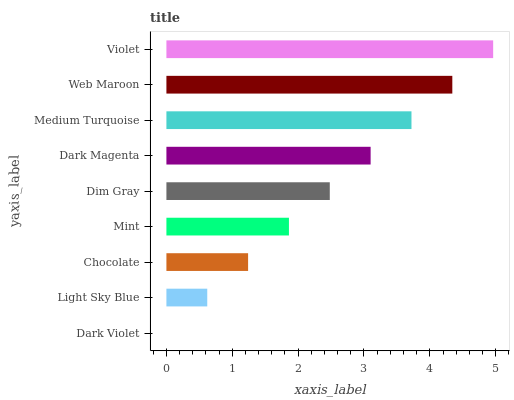Is Dark Violet the minimum?
Answer yes or no. Yes. Is Violet the maximum?
Answer yes or no. Yes. Is Light Sky Blue the minimum?
Answer yes or no. No. Is Light Sky Blue the maximum?
Answer yes or no. No. Is Light Sky Blue greater than Dark Violet?
Answer yes or no. Yes. Is Dark Violet less than Light Sky Blue?
Answer yes or no. Yes. Is Dark Violet greater than Light Sky Blue?
Answer yes or no. No. Is Light Sky Blue less than Dark Violet?
Answer yes or no. No. Is Dim Gray the high median?
Answer yes or no. Yes. Is Dim Gray the low median?
Answer yes or no. Yes. Is Dark Violet the high median?
Answer yes or no. No. Is Dark Magenta the low median?
Answer yes or no. No. 